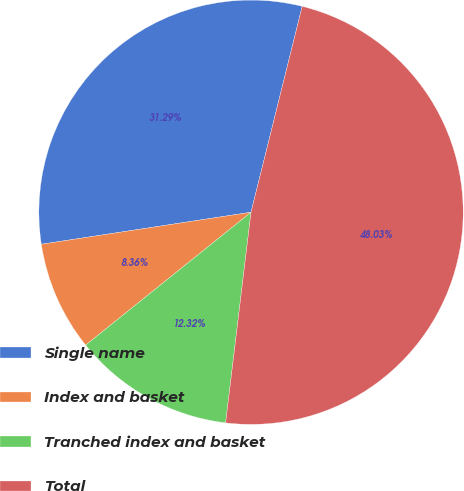Convert chart to OTSL. <chart><loc_0><loc_0><loc_500><loc_500><pie_chart><fcel>Single name<fcel>Index and basket<fcel>Tranched index and basket<fcel>Total<nl><fcel>31.29%<fcel>8.36%<fcel>12.32%<fcel>48.03%<nl></chart> 